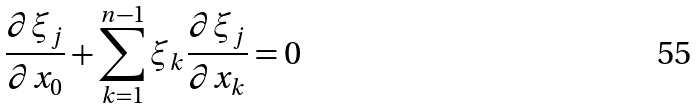<formula> <loc_0><loc_0><loc_500><loc_500>\frac { \partial \xi _ { j } } { \partial x _ { 0 } } + \sum _ { k = 1 } ^ { n - 1 } \xi _ { k } \frac { \partial \xi _ { j } } { \partial x _ { k } } = 0</formula> 